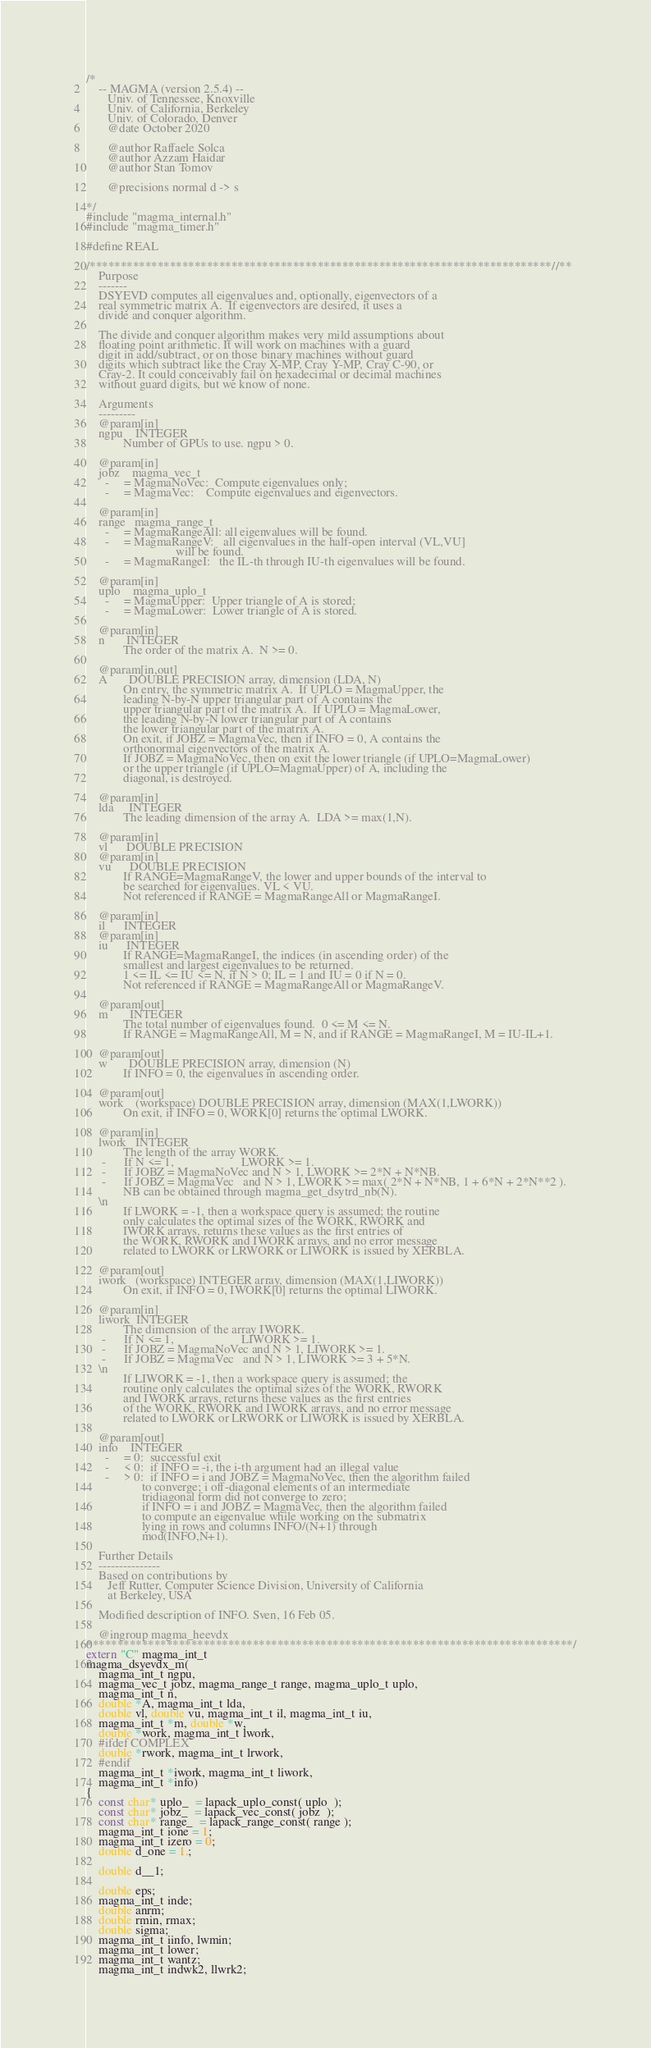Convert code to text. <code><loc_0><loc_0><loc_500><loc_500><_C++_>/*
    -- MAGMA (version 2.5.4) --
       Univ. of Tennessee, Knoxville
       Univ. of California, Berkeley
       Univ. of Colorado, Denver
       @date October 2020

       @author Raffaele Solca
       @author Azzam Haidar
       @author Stan Tomov

       @precisions normal d -> s

*/
#include "magma_internal.h"
#include "magma_timer.h"

#define REAL

/***************************************************************************//**
    Purpose
    -------
    DSYEVD computes all eigenvalues and, optionally, eigenvectors of a
    real symmetric matrix A.  If eigenvectors are desired, it uses a
    divide and conquer algorithm.

    The divide and conquer algorithm makes very mild assumptions about
    floating point arithmetic. It will work on machines with a guard
    digit in add/subtract, or on those binary machines without guard
    digits which subtract like the Cray X-MP, Cray Y-MP, Cray C-90, or
    Cray-2. It could conceivably fail on hexadecimal or decimal machines
    without guard digits, but we know of none.

    Arguments
    ---------
    @param[in]
    ngpu    INTEGER
            Number of GPUs to use. ngpu > 0.

    @param[in]
    jobz    magma_vec_t
      -     = MagmaNoVec:  Compute eigenvalues only;
      -     = MagmaVec:    Compute eigenvalues and eigenvectors.

    @param[in]
    range   magma_range_t
      -     = MagmaRangeAll: all eigenvalues will be found.
      -     = MagmaRangeV:   all eigenvalues in the half-open interval (VL,VU]
                             will be found.
      -     = MagmaRangeI:   the IL-th through IU-th eigenvalues will be found.

    @param[in]
    uplo    magma_uplo_t
      -     = MagmaUpper:  Upper triangle of A is stored;
      -     = MagmaLower:  Lower triangle of A is stored.

    @param[in]
    n       INTEGER
            The order of the matrix A.  N >= 0.

    @param[in,out]
    A       DOUBLE PRECISION array, dimension (LDA, N)
            On entry, the symmetric matrix A.  If UPLO = MagmaUpper, the
            leading N-by-N upper triangular part of A contains the
            upper triangular part of the matrix A.  If UPLO = MagmaLower,
            the leading N-by-N lower triangular part of A contains
            the lower triangular part of the matrix A.
            On exit, if JOBZ = MagmaVec, then if INFO = 0, A contains the
            orthonormal eigenvectors of the matrix A.
            If JOBZ = MagmaNoVec, then on exit the lower triangle (if UPLO=MagmaLower)
            or the upper triangle (if UPLO=MagmaUpper) of A, including the
            diagonal, is destroyed.

    @param[in]
    lda     INTEGER
            The leading dimension of the array A.  LDA >= max(1,N).

    @param[in]
    vl      DOUBLE PRECISION
    @param[in]
    vu      DOUBLE PRECISION
            If RANGE=MagmaRangeV, the lower and upper bounds of the interval to
            be searched for eigenvalues. VL < VU.
            Not referenced if RANGE = MagmaRangeAll or MagmaRangeI.

    @param[in]
    il      INTEGER
    @param[in]
    iu      INTEGER
            If RANGE=MagmaRangeI, the indices (in ascending order) of the
            smallest and largest eigenvalues to be returned.
            1 <= IL <= IU <= N, if N > 0; IL = 1 and IU = 0 if N = 0.
            Not referenced if RANGE = MagmaRangeAll or MagmaRangeV.

    @param[out]
    m       INTEGER
            The total number of eigenvalues found.  0 <= M <= N.
            If RANGE = MagmaRangeAll, M = N, and if RANGE = MagmaRangeI, M = IU-IL+1.

    @param[out]
    w       DOUBLE PRECISION array, dimension (N)
            If INFO = 0, the eigenvalues in ascending order.

    @param[out]
    work    (workspace) DOUBLE PRECISION array, dimension (MAX(1,LWORK))
            On exit, if INFO = 0, WORK[0] returns the optimal LWORK.

    @param[in]
    lwork   INTEGER
            The length of the array WORK.
     -      If N <= 1,                      LWORK >= 1.
     -      If JOBZ = MagmaNoVec and N > 1, LWORK >= 2*N + N*NB.
     -      If JOBZ = MagmaVec   and N > 1, LWORK >= max( 2*N + N*NB, 1 + 6*N + 2*N**2 ).
            NB can be obtained through magma_get_dsytrd_nb(N).
    \n
            If LWORK = -1, then a workspace query is assumed; the routine
            only calculates the optimal sizes of the WORK, RWORK and
            IWORK arrays, returns these values as the first entries of
            the WORK, RWORK and IWORK arrays, and no error message
            related to LWORK or LRWORK or LIWORK is issued by XERBLA.

    @param[out]
    iwork   (workspace) INTEGER array, dimension (MAX(1,LIWORK))
            On exit, if INFO = 0, IWORK[0] returns the optimal LIWORK.

    @param[in]
    liwork  INTEGER
            The dimension of the array IWORK.
     -      If N <= 1,                      LIWORK >= 1.
     -      If JOBZ = MagmaNoVec and N > 1, LIWORK >= 1.
     -      If JOBZ = MagmaVec   and N > 1, LIWORK >= 3 + 5*N.
    \n
            If LIWORK = -1, then a workspace query is assumed; the
            routine only calculates the optimal sizes of the WORK, RWORK
            and IWORK arrays, returns these values as the first entries
            of the WORK, RWORK and IWORK arrays, and no error message
            related to LWORK or LRWORK or LIWORK is issued by XERBLA.

    @param[out]
    info    INTEGER
      -     = 0:  successful exit
      -     < 0:  if INFO = -i, the i-th argument had an illegal value
      -     > 0:  if INFO = i and JOBZ = MagmaNoVec, then the algorithm failed
                  to converge; i off-diagonal elements of an intermediate
                  tridiagonal form did not converge to zero;
                  if INFO = i and JOBZ = MagmaVec, then the algorithm failed
                  to compute an eigenvalue while working on the submatrix
                  lying in rows and columns INFO/(N+1) through
                  mod(INFO,N+1).

    Further Details
    ---------------
    Based on contributions by
       Jeff Rutter, Computer Science Division, University of California
       at Berkeley, USA

    Modified description of INFO. Sven, 16 Feb 05.

    @ingroup magma_heevdx
*******************************************************************************/
extern "C" magma_int_t
magma_dsyevdx_m(
    magma_int_t ngpu,
    magma_vec_t jobz, magma_range_t range, magma_uplo_t uplo,
    magma_int_t n,
    double *A, magma_int_t lda,
    double vl, double vu, magma_int_t il, magma_int_t iu,
    magma_int_t *m, double *w,
    double *work, magma_int_t lwork,
    #ifdef COMPLEX
    double *rwork, magma_int_t lrwork,
    #endif
    magma_int_t *iwork, magma_int_t liwork,
    magma_int_t *info)
{
    const char* uplo_  = lapack_uplo_const( uplo  );
    const char* jobz_  = lapack_vec_const( jobz  );
    const char* range_  = lapack_range_const( range );
    magma_int_t ione = 1;
    magma_int_t izero = 0;
    double d_one = 1.;
    
    double d__1;
    
    double eps;
    magma_int_t inde;
    double anrm;
    double rmin, rmax;
    double sigma;
    magma_int_t iinfo, lwmin;
    magma_int_t lower;
    magma_int_t wantz;
    magma_int_t indwk2, llwrk2;</code> 